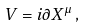<formula> <loc_0><loc_0><loc_500><loc_500>V = i \partial X ^ { \mu } \, ,</formula> 